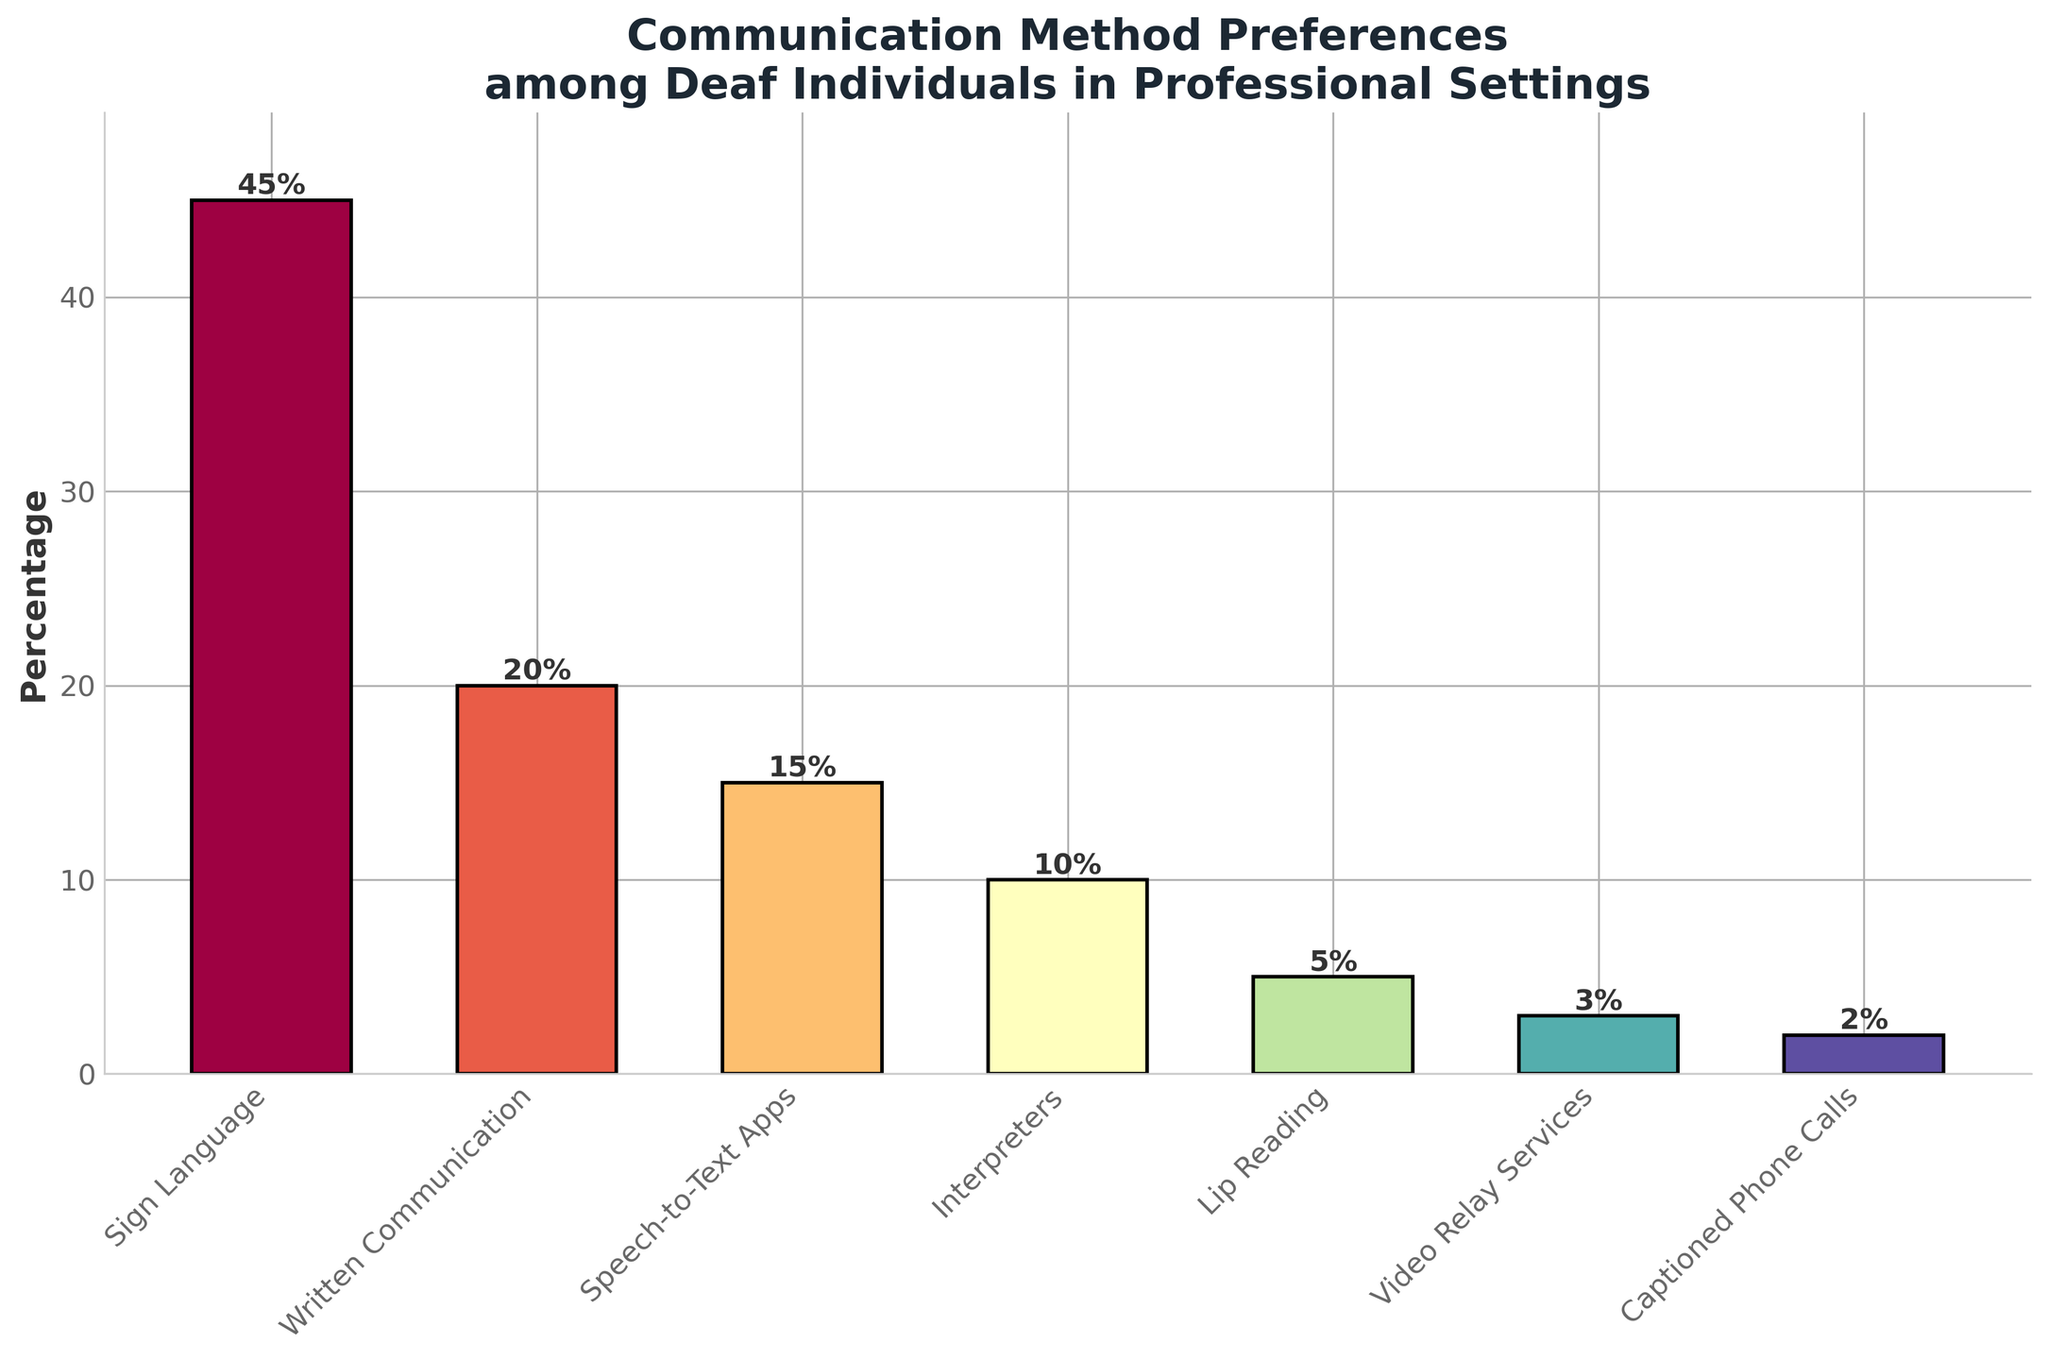Which communication method is the most preferred among deaf individuals in professional settings? The method with the highest bar and percentage indicated in the figure represents the most preferred communication method. In this plot, Sign Language has the tallest bar and the highest percentage at 45%.
Answer: Sign Language What is the combined preference percentage for Written Communication and Speech-to-Text Apps? To find the combined percentage, add the percentages for Written Communication (20%) and Speech-to-Text Apps (15%). 20% + 15% = 35%.
Answer: 35% How does the preference for Interpreters compare to that for Lip Reading? Look at the heights of the bars for Interpreters and Lip Reading. Interpreters have a higher percentage (10%) compared to Lip Reading (5%).
Answer: Interpreters is preferred more What is the percentage point difference between the most and least preferred methods? Identify the highest percentage (Sign Language at 45%) and the lowest percentage (Captioned Phone Calls at 2%). Compute the difference: 45% - 2% = 43%.
Answer: 43% How many methods have a preference percentage less than 10%? Count the bars with percentages less than 10%. Interpreters (10%), Lip Reading (5%), Video Relay Services (3%), and Captioned Phone Calls (2%) fall into this range. Hence, there are three methods.
Answer: 3 Which two methods have the closest preference percentages? By examining the bars, Written Communication (20%) and Speech-to-Text Apps (15%) have the smallest difference, which is 5%.
Answer: Written Communication and Speech-to-Text Apps What proportion of the total preference is for methods other than Sign Language? Calculate 100% - percentage for Sign Language (45%) to find the combined percentage for all other methods. 100% - 45% = 55%.
Answer: 55% What is the average preference percentage for all communication methods? Add all the percentages and divide by the number of methods: (45 + 20 + 15 + 10 + 5 + 3 + 2) / 7 = 100 / 7 ≈ 14.29%.
Answer: 14.29% Which method, Written Communication or Interpreters, has a higher preference, and by how much? Written Communication has a percentage of 20% and Interpreters have 10%. The difference is 20% - 10% = 10%.
Answer: Written Communication by 10% By how much does the preference for Video Relay Services exceed that for Captioned Phone Calls? Video Relay Services have a percentage of 3% and Captioned Phone Calls have 2%. The difference is 3% - 2% = 1%.
Answer: 1% 